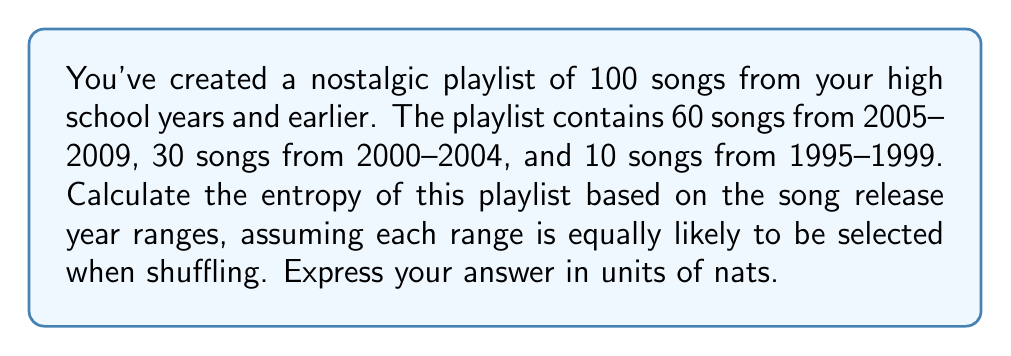Can you answer this question? To calculate the entropy of the playlist, we'll use the Shannon entropy formula:

$$ S = -\sum_{i=1}^n p_i \ln(p_i) $$

Where $S$ is the entropy, $p_i$ is the probability of each state, and $n$ is the number of states.

Step 1: Calculate the probabilities for each year range:
- 2005-2009: $p_1 = 60/100 = 0.6$
- 2000-2004: $p_2 = 30/100 = 0.3$
- 1995-1999: $p_3 = 10/100 = 0.1$

Step 2: Apply the entropy formula:

$$ S = -[0.6 \ln(0.6) + 0.3 \ln(0.3) + 0.1 \ln(0.1)] $$

Step 3: Calculate each term:
- $0.6 \ln(0.6) \approx -0.3067$
- $0.3 \ln(0.3) \approx -0.3611$
- $0.1 \ln(0.1) \approx -0.2303$

Step 4: Sum the terms and take the negative:

$$ S = -[-0.3067 - 0.3611 - 0.2303] $$
$$ S = 0.8981 \text{ nats} $$
Answer: 0.8981 nats 